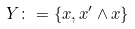Convert formula to latex. <formula><loc_0><loc_0><loc_500><loc_500>Y \colon = \{ x , x ^ { \prime } \wedge x \}</formula> 